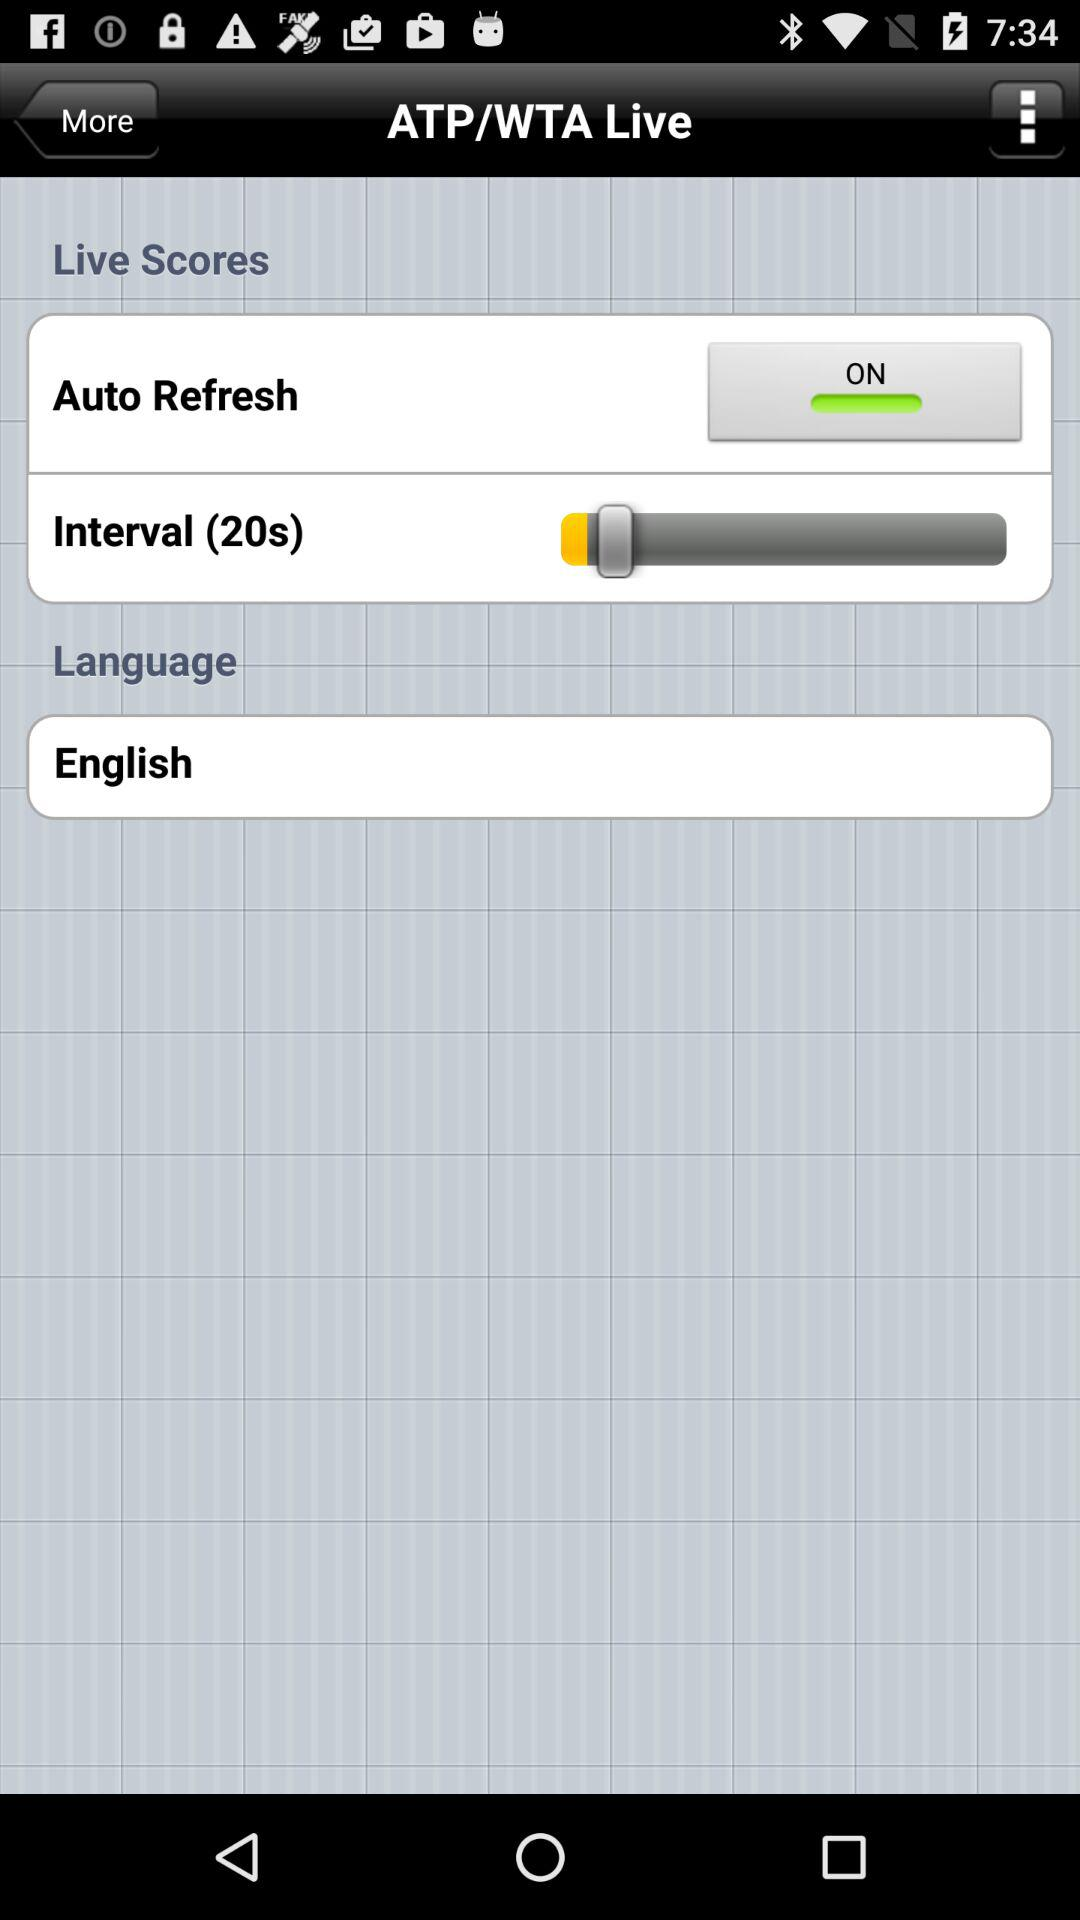What is the language? The language is English. 